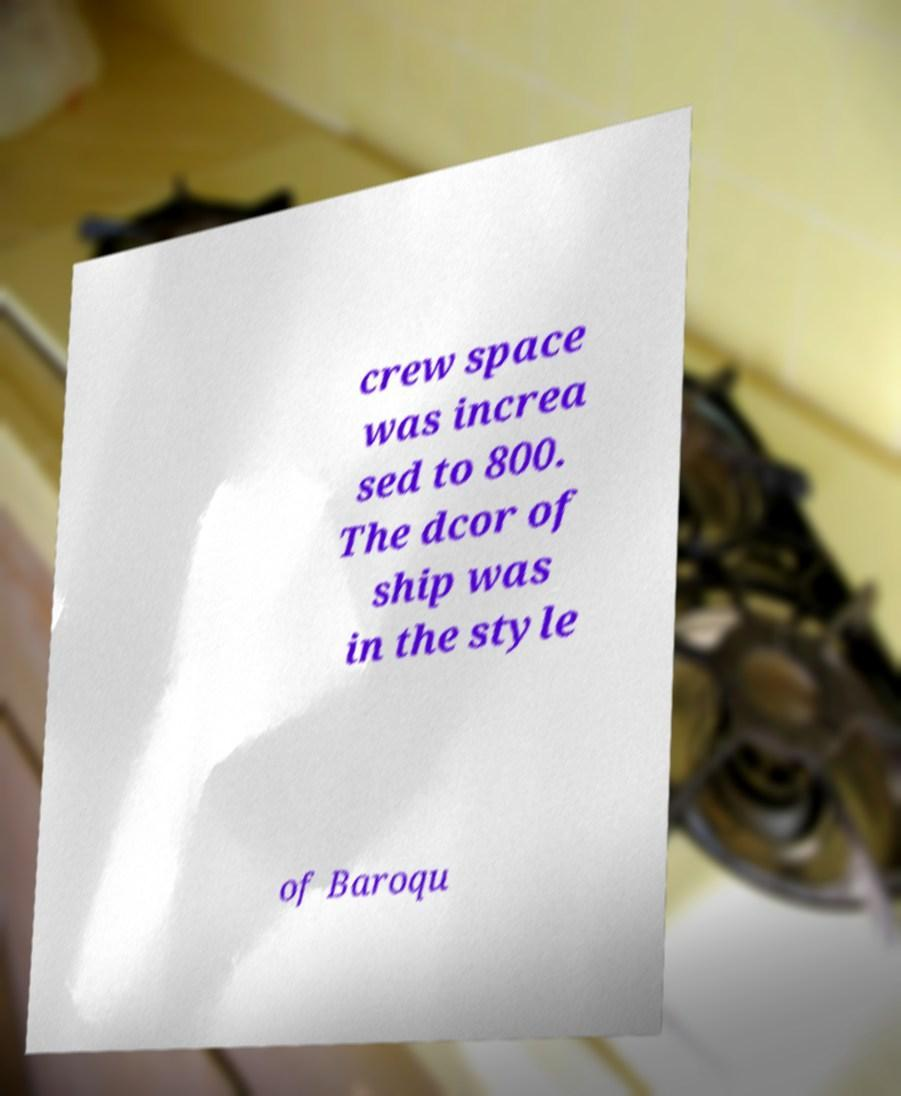Please identify and transcribe the text found in this image. crew space was increa sed to 800. The dcor of ship was in the style of Baroqu 